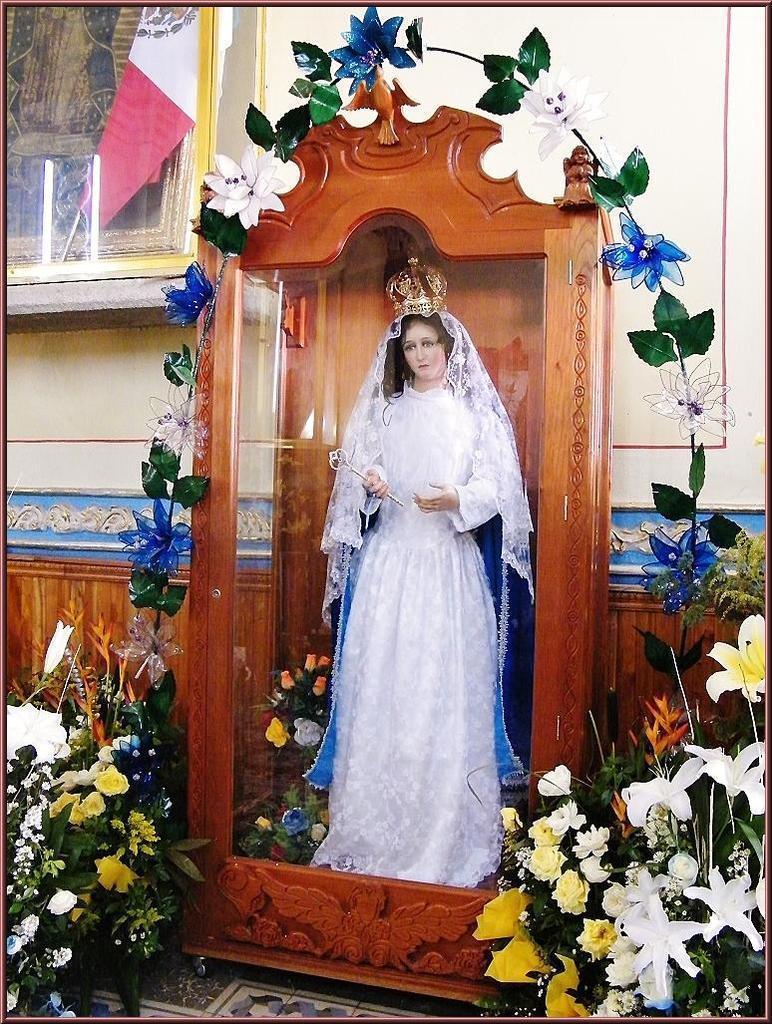Please provide a concise description of this image. In the foreground of this picture, there is a woman statue in the cupboard and the artificial flowers to the plants are around it. In the background, there is wall and a glass frame. 